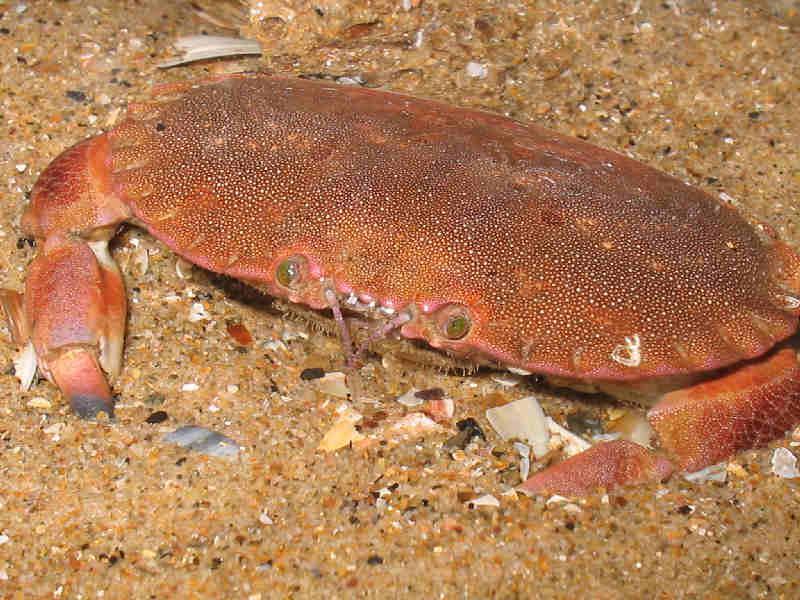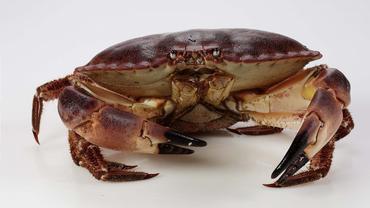The first image is the image on the left, the second image is the image on the right. For the images displayed, is the sentence "The left and right images each show only one crab, and one of the pictured crabs is on a white background and has black-tipped front claws." factually correct? Answer yes or no. Yes. The first image is the image on the left, the second image is the image on the right. Considering the images on both sides, is "The right image contains no more than one crab." valid? Answer yes or no. Yes. 